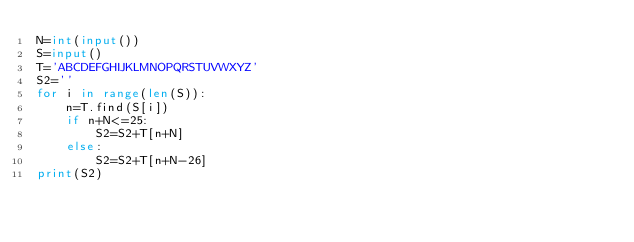Convert code to text. <code><loc_0><loc_0><loc_500><loc_500><_Python_>N=int(input())
S=input()
T='ABCDEFGHIJKLMNOPQRSTUVWXYZ'
S2=''
for i in range(len(S)):
    n=T.find(S[i])
    if n+N<=25:
        S2=S2+T[n+N]
    else:
        S2=S2+T[n+N-26]
print(S2)
        </code> 